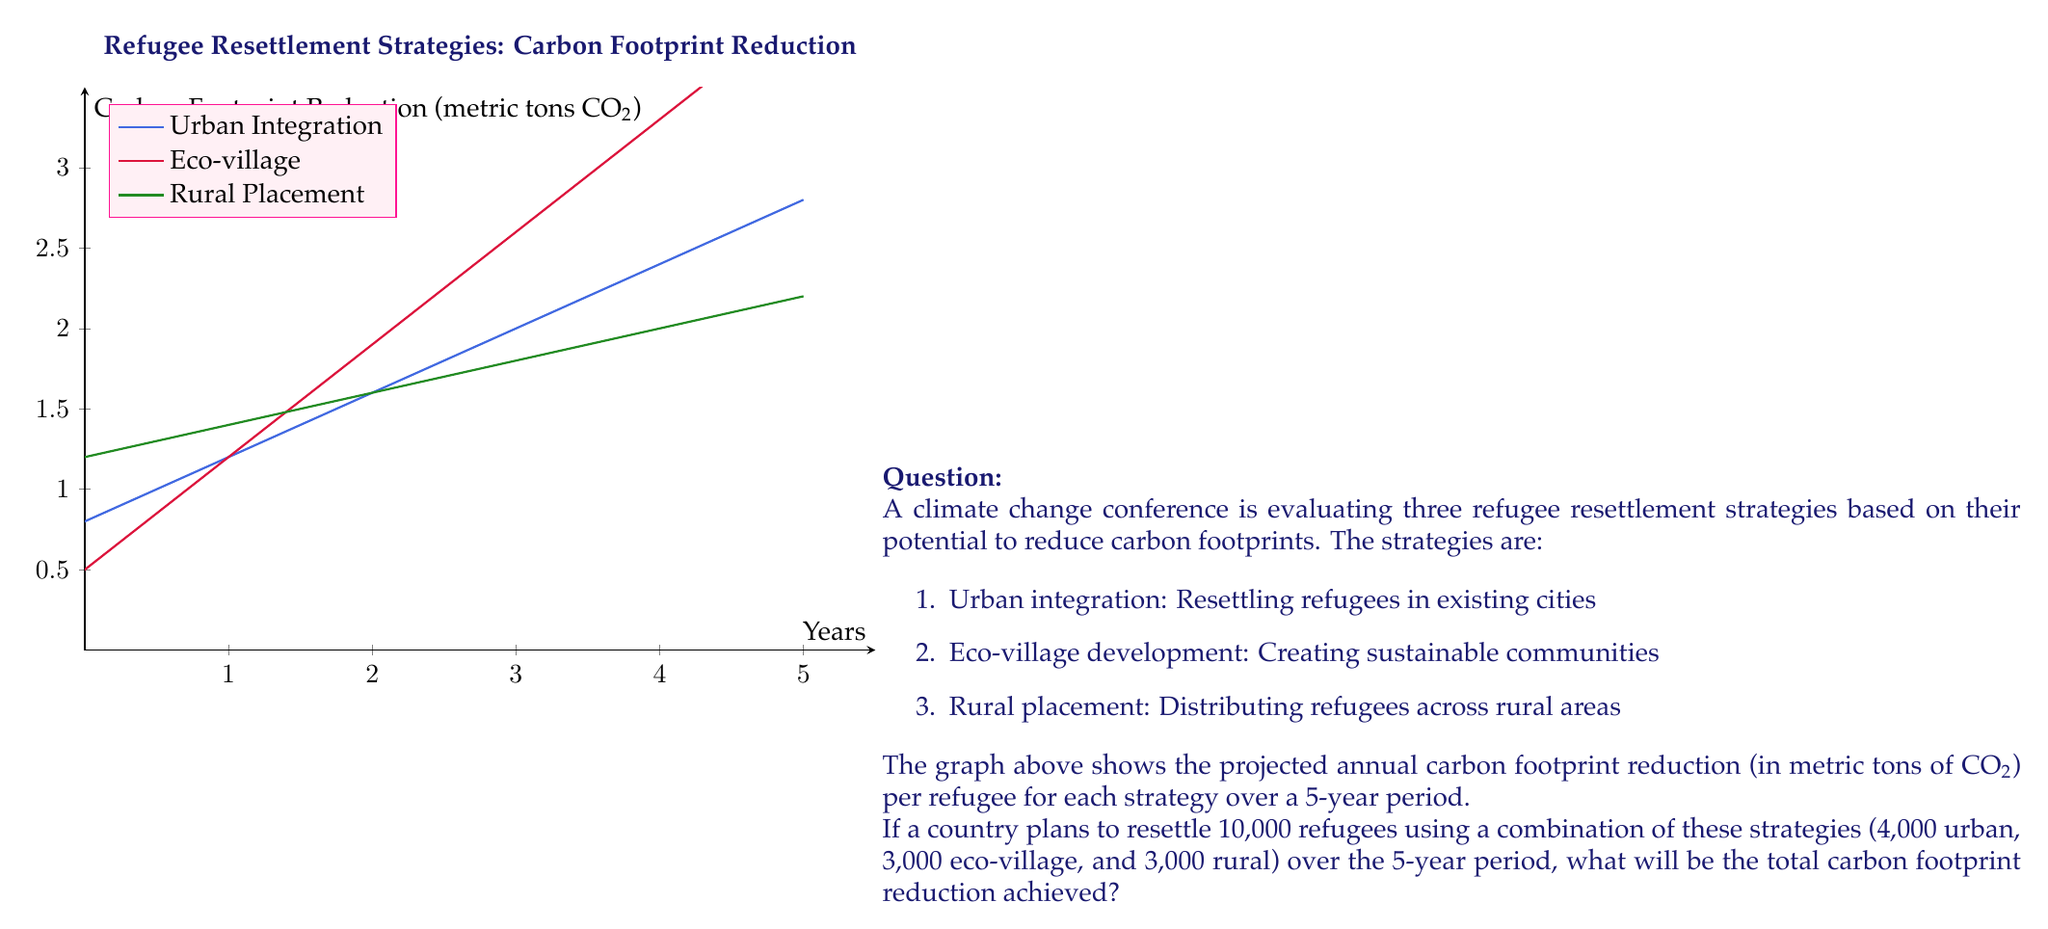Provide a solution to this math problem. To solve this problem, we need to:
1. Determine the carbon footprint reduction for each strategy over 5 years
2. Calculate the total reduction for each strategy based on the number of refugees
3. Sum up the reductions from all strategies

Step 1: Determine carbon footprint reduction per refugee over 5 years

For each strategy, we can use the linear equation $y = mx + b$, where:
$y$ = carbon footprint reduction
$m$ = slope (annual increase in reduction)
$x$ = number of years
$b$ = initial reduction (y-intercept)

Urban integration: $y = 0.4x + 0.8$
At year 5: $y = 0.4(5) + 0.8 = 2.8$ metric tons CO₂

Eco-village: $y = 0.7x + 0.5$
At year 5: $y = 0.7(5) + 0.5 = 4.0$ metric tons CO₂

Rural placement: $y = 0.2x + 1.2$
At year 5: $y = 0.2(5) + 1.2 = 2.2$ metric tons CO₂

Step 2: Calculate total reduction for each strategy

Urban integration: $4,000 \times 2.8 = 11,200$ metric tons CO₂
Eco-village: $3,000 \times 4.0 = 12,000$ metric tons CO₂
Rural placement: $3,000 \times 2.2 = 6,600$ metric tons CO₂

Step 3: Sum up the reductions

Total reduction = Urban + Eco-village + Rural
$$ 11,200 + 12,000 + 6,600 = 29,800 \text{ metric tons CO₂} $$
Answer: 29,800 metric tons CO₂ 